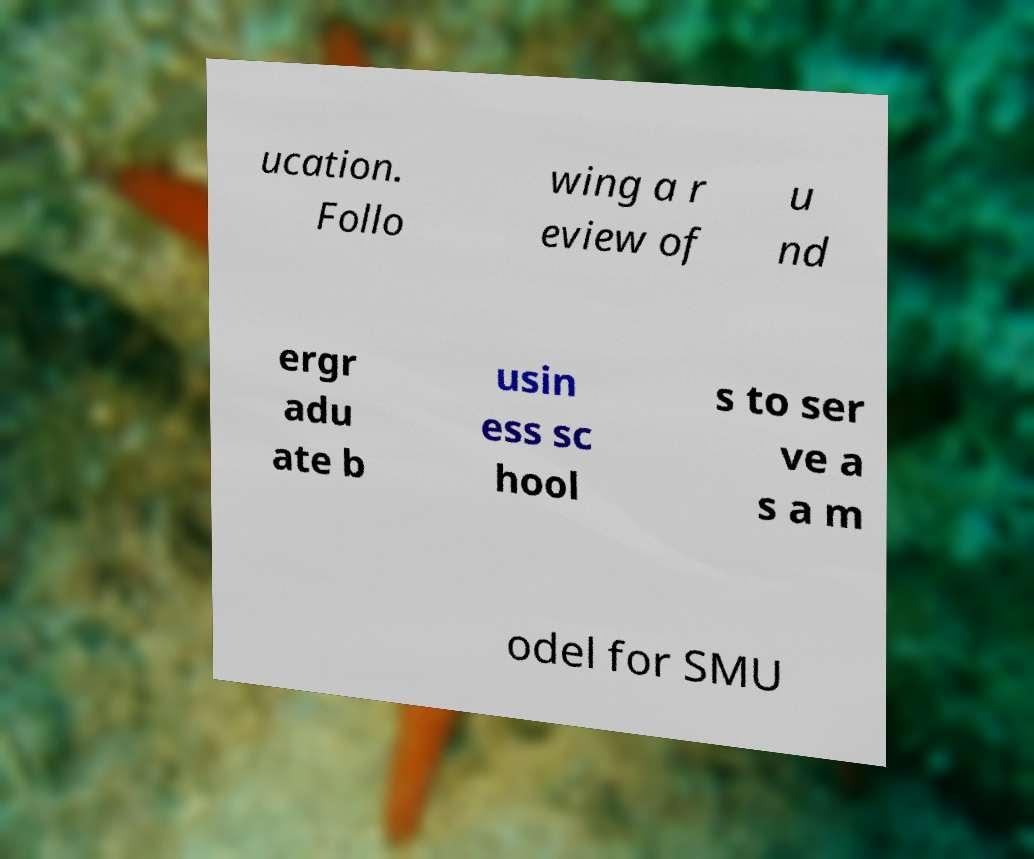Could you assist in decoding the text presented in this image and type it out clearly? ucation. Follo wing a r eview of u nd ergr adu ate b usin ess sc hool s to ser ve a s a m odel for SMU 